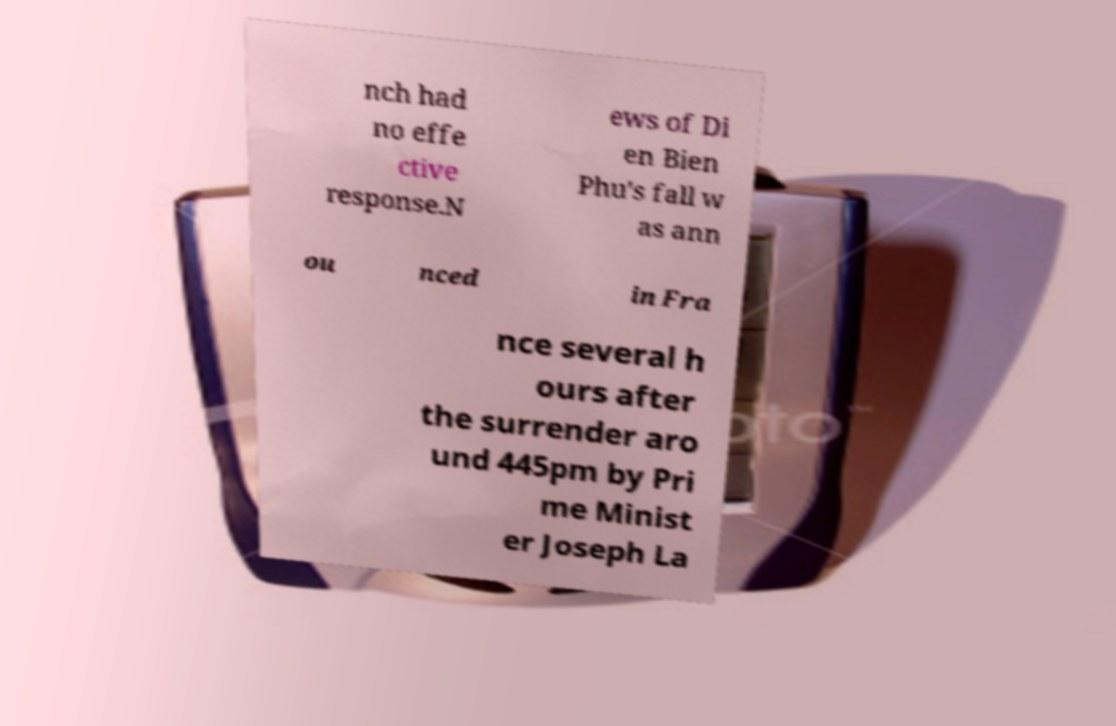There's text embedded in this image that I need extracted. Can you transcribe it verbatim? nch had no effe ctive response.N ews of Di en Bien Phu's fall w as ann ou nced in Fra nce several h ours after the surrender aro und 445pm by Pri me Minist er Joseph La 